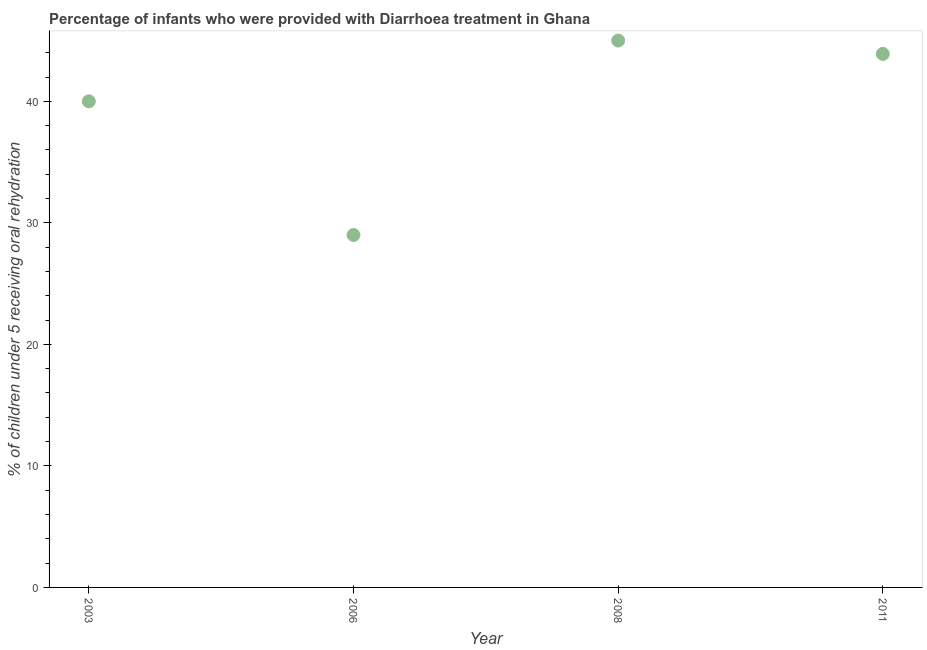Across all years, what is the minimum percentage of children who were provided with treatment diarrhoea?
Make the answer very short. 29. What is the sum of the percentage of children who were provided with treatment diarrhoea?
Your answer should be very brief. 157.9. What is the difference between the percentage of children who were provided with treatment diarrhoea in 2008 and 2011?
Offer a very short reply. 1.1. What is the average percentage of children who were provided with treatment diarrhoea per year?
Make the answer very short. 39.48. What is the median percentage of children who were provided with treatment diarrhoea?
Keep it short and to the point. 41.95. In how many years, is the percentage of children who were provided with treatment diarrhoea greater than 40 %?
Your answer should be compact. 2. What is the ratio of the percentage of children who were provided with treatment diarrhoea in 2006 to that in 2011?
Give a very brief answer. 0.66. Is the percentage of children who were provided with treatment diarrhoea in 2006 less than that in 2008?
Ensure brevity in your answer.  Yes. Is the difference between the percentage of children who were provided with treatment diarrhoea in 2003 and 2008 greater than the difference between any two years?
Your answer should be very brief. No. What is the difference between the highest and the second highest percentage of children who were provided with treatment diarrhoea?
Offer a terse response. 1.1. Does the percentage of children who were provided with treatment diarrhoea monotonically increase over the years?
Your answer should be compact. No. How many years are there in the graph?
Give a very brief answer. 4. Does the graph contain grids?
Offer a terse response. No. What is the title of the graph?
Give a very brief answer. Percentage of infants who were provided with Diarrhoea treatment in Ghana. What is the label or title of the X-axis?
Your answer should be very brief. Year. What is the label or title of the Y-axis?
Your answer should be compact. % of children under 5 receiving oral rehydration. What is the % of children under 5 receiving oral rehydration in 2006?
Provide a succinct answer. 29. What is the % of children under 5 receiving oral rehydration in 2011?
Your answer should be very brief. 43.9. What is the difference between the % of children under 5 receiving oral rehydration in 2003 and 2008?
Give a very brief answer. -5. What is the difference between the % of children under 5 receiving oral rehydration in 2006 and 2011?
Make the answer very short. -14.9. What is the difference between the % of children under 5 receiving oral rehydration in 2008 and 2011?
Provide a short and direct response. 1.1. What is the ratio of the % of children under 5 receiving oral rehydration in 2003 to that in 2006?
Offer a very short reply. 1.38. What is the ratio of the % of children under 5 receiving oral rehydration in 2003 to that in 2008?
Your response must be concise. 0.89. What is the ratio of the % of children under 5 receiving oral rehydration in 2003 to that in 2011?
Ensure brevity in your answer.  0.91. What is the ratio of the % of children under 5 receiving oral rehydration in 2006 to that in 2008?
Provide a succinct answer. 0.64. What is the ratio of the % of children under 5 receiving oral rehydration in 2006 to that in 2011?
Ensure brevity in your answer.  0.66. What is the ratio of the % of children under 5 receiving oral rehydration in 2008 to that in 2011?
Your response must be concise. 1.02. 